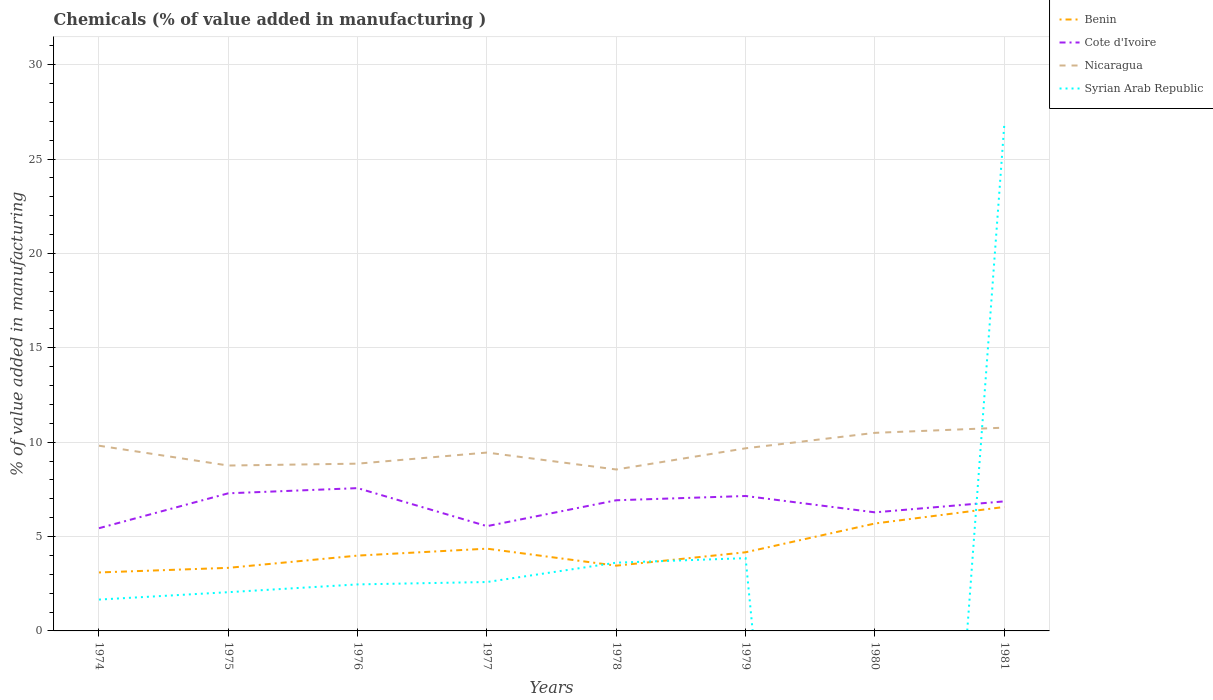How many different coloured lines are there?
Your answer should be very brief. 4. Across all years, what is the maximum value added in manufacturing chemicals in Nicaragua?
Offer a terse response. 8.55. What is the total value added in manufacturing chemicals in Benin in the graph?
Provide a succinct answer. -2.21. What is the difference between the highest and the second highest value added in manufacturing chemicals in Cote d'Ivoire?
Offer a very short reply. 2.12. What is the difference between the highest and the lowest value added in manufacturing chemicals in Cote d'Ivoire?
Ensure brevity in your answer.  5. Is the value added in manufacturing chemicals in Nicaragua strictly greater than the value added in manufacturing chemicals in Syrian Arab Republic over the years?
Make the answer very short. No. How many years are there in the graph?
Give a very brief answer. 8. What is the difference between two consecutive major ticks on the Y-axis?
Keep it short and to the point. 5. Are the values on the major ticks of Y-axis written in scientific E-notation?
Your response must be concise. No. Where does the legend appear in the graph?
Your answer should be compact. Top right. What is the title of the graph?
Provide a short and direct response. Chemicals (% of value added in manufacturing ). Does "Latvia" appear as one of the legend labels in the graph?
Your response must be concise. No. What is the label or title of the Y-axis?
Make the answer very short. % of value added in manufacturing. What is the % of value added in manufacturing in Benin in 1974?
Your response must be concise. 3.1. What is the % of value added in manufacturing in Cote d'Ivoire in 1974?
Provide a short and direct response. 5.44. What is the % of value added in manufacturing of Nicaragua in 1974?
Your response must be concise. 9.81. What is the % of value added in manufacturing in Syrian Arab Republic in 1974?
Your response must be concise. 1.66. What is the % of value added in manufacturing in Benin in 1975?
Your answer should be very brief. 3.34. What is the % of value added in manufacturing in Cote d'Ivoire in 1975?
Offer a very short reply. 7.29. What is the % of value added in manufacturing of Nicaragua in 1975?
Provide a short and direct response. 8.76. What is the % of value added in manufacturing in Syrian Arab Republic in 1975?
Offer a very short reply. 2.05. What is the % of value added in manufacturing in Benin in 1976?
Provide a short and direct response. 3.99. What is the % of value added in manufacturing of Cote d'Ivoire in 1976?
Your response must be concise. 7.56. What is the % of value added in manufacturing of Nicaragua in 1976?
Make the answer very short. 8.86. What is the % of value added in manufacturing in Syrian Arab Republic in 1976?
Your answer should be very brief. 2.46. What is the % of value added in manufacturing in Benin in 1977?
Your answer should be compact. 4.36. What is the % of value added in manufacturing of Cote d'Ivoire in 1977?
Make the answer very short. 5.55. What is the % of value added in manufacturing in Nicaragua in 1977?
Offer a terse response. 9.45. What is the % of value added in manufacturing of Syrian Arab Republic in 1977?
Ensure brevity in your answer.  2.59. What is the % of value added in manufacturing in Benin in 1978?
Ensure brevity in your answer.  3.46. What is the % of value added in manufacturing in Cote d'Ivoire in 1978?
Provide a short and direct response. 6.92. What is the % of value added in manufacturing of Nicaragua in 1978?
Ensure brevity in your answer.  8.55. What is the % of value added in manufacturing in Syrian Arab Republic in 1978?
Provide a succinct answer. 3.62. What is the % of value added in manufacturing in Benin in 1979?
Give a very brief answer. 4.17. What is the % of value added in manufacturing of Cote d'Ivoire in 1979?
Your answer should be compact. 7.15. What is the % of value added in manufacturing in Nicaragua in 1979?
Offer a terse response. 9.68. What is the % of value added in manufacturing in Syrian Arab Republic in 1979?
Make the answer very short. 3.85. What is the % of value added in manufacturing in Benin in 1980?
Provide a succinct answer. 5.69. What is the % of value added in manufacturing in Cote d'Ivoire in 1980?
Provide a succinct answer. 6.28. What is the % of value added in manufacturing in Nicaragua in 1980?
Make the answer very short. 10.49. What is the % of value added in manufacturing of Benin in 1981?
Provide a succinct answer. 6.57. What is the % of value added in manufacturing in Cote d'Ivoire in 1981?
Keep it short and to the point. 6.86. What is the % of value added in manufacturing in Nicaragua in 1981?
Offer a terse response. 10.77. What is the % of value added in manufacturing of Syrian Arab Republic in 1981?
Provide a short and direct response. 26.81. Across all years, what is the maximum % of value added in manufacturing of Benin?
Your answer should be compact. 6.57. Across all years, what is the maximum % of value added in manufacturing of Cote d'Ivoire?
Your answer should be compact. 7.56. Across all years, what is the maximum % of value added in manufacturing in Nicaragua?
Make the answer very short. 10.77. Across all years, what is the maximum % of value added in manufacturing of Syrian Arab Republic?
Make the answer very short. 26.81. Across all years, what is the minimum % of value added in manufacturing in Benin?
Offer a very short reply. 3.1. Across all years, what is the minimum % of value added in manufacturing of Cote d'Ivoire?
Ensure brevity in your answer.  5.44. Across all years, what is the minimum % of value added in manufacturing in Nicaragua?
Your answer should be very brief. 8.55. What is the total % of value added in manufacturing in Benin in the graph?
Provide a short and direct response. 34.67. What is the total % of value added in manufacturing in Cote d'Ivoire in the graph?
Offer a terse response. 53.07. What is the total % of value added in manufacturing in Nicaragua in the graph?
Offer a very short reply. 76.38. What is the total % of value added in manufacturing in Syrian Arab Republic in the graph?
Keep it short and to the point. 43.05. What is the difference between the % of value added in manufacturing in Benin in 1974 and that in 1975?
Your answer should be compact. -0.24. What is the difference between the % of value added in manufacturing in Cote d'Ivoire in 1974 and that in 1975?
Ensure brevity in your answer.  -1.85. What is the difference between the % of value added in manufacturing in Nicaragua in 1974 and that in 1975?
Provide a short and direct response. 1.05. What is the difference between the % of value added in manufacturing in Syrian Arab Republic in 1974 and that in 1975?
Offer a very short reply. -0.39. What is the difference between the % of value added in manufacturing of Benin in 1974 and that in 1976?
Give a very brief answer. -0.89. What is the difference between the % of value added in manufacturing in Cote d'Ivoire in 1974 and that in 1976?
Keep it short and to the point. -2.12. What is the difference between the % of value added in manufacturing of Nicaragua in 1974 and that in 1976?
Ensure brevity in your answer.  0.95. What is the difference between the % of value added in manufacturing in Syrian Arab Republic in 1974 and that in 1976?
Offer a terse response. -0.8. What is the difference between the % of value added in manufacturing of Benin in 1974 and that in 1977?
Give a very brief answer. -1.26. What is the difference between the % of value added in manufacturing in Cote d'Ivoire in 1974 and that in 1977?
Your answer should be compact. -0.11. What is the difference between the % of value added in manufacturing in Nicaragua in 1974 and that in 1977?
Offer a very short reply. 0.36. What is the difference between the % of value added in manufacturing in Syrian Arab Republic in 1974 and that in 1977?
Your answer should be compact. -0.93. What is the difference between the % of value added in manufacturing in Benin in 1974 and that in 1978?
Offer a very short reply. -0.36. What is the difference between the % of value added in manufacturing in Cote d'Ivoire in 1974 and that in 1978?
Your answer should be very brief. -1.48. What is the difference between the % of value added in manufacturing of Nicaragua in 1974 and that in 1978?
Your answer should be very brief. 1.26. What is the difference between the % of value added in manufacturing in Syrian Arab Republic in 1974 and that in 1978?
Your answer should be very brief. -1.95. What is the difference between the % of value added in manufacturing of Benin in 1974 and that in 1979?
Your answer should be very brief. -1.07. What is the difference between the % of value added in manufacturing of Cote d'Ivoire in 1974 and that in 1979?
Offer a very short reply. -1.71. What is the difference between the % of value added in manufacturing of Nicaragua in 1974 and that in 1979?
Keep it short and to the point. 0.14. What is the difference between the % of value added in manufacturing in Syrian Arab Republic in 1974 and that in 1979?
Provide a short and direct response. -2.19. What is the difference between the % of value added in manufacturing in Benin in 1974 and that in 1980?
Provide a succinct answer. -2.59. What is the difference between the % of value added in manufacturing in Cote d'Ivoire in 1974 and that in 1980?
Provide a succinct answer. -0.84. What is the difference between the % of value added in manufacturing in Nicaragua in 1974 and that in 1980?
Offer a terse response. -0.68. What is the difference between the % of value added in manufacturing of Benin in 1974 and that in 1981?
Keep it short and to the point. -3.47. What is the difference between the % of value added in manufacturing of Cote d'Ivoire in 1974 and that in 1981?
Give a very brief answer. -1.42. What is the difference between the % of value added in manufacturing of Nicaragua in 1974 and that in 1981?
Your answer should be very brief. -0.96. What is the difference between the % of value added in manufacturing of Syrian Arab Republic in 1974 and that in 1981?
Make the answer very short. -25.15. What is the difference between the % of value added in manufacturing in Benin in 1975 and that in 1976?
Give a very brief answer. -0.65. What is the difference between the % of value added in manufacturing in Cote d'Ivoire in 1975 and that in 1976?
Your answer should be very brief. -0.27. What is the difference between the % of value added in manufacturing in Nicaragua in 1975 and that in 1976?
Provide a succinct answer. -0.1. What is the difference between the % of value added in manufacturing in Syrian Arab Republic in 1975 and that in 1976?
Your answer should be very brief. -0.41. What is the difference between the % of value added in manufacturing in Benin in 1975 and that in 1977?
Provide a short and direct response. -1.02. What is the difference between the % of value added in manufacturing in Cote d'Ivoire in 1975 and that in 1977?
Provide a succinct answer. 1.74. What is the difference between the % of value added in manufacturing in Nicaragua in 1975 and that in 1977?
Offer a very short reply. -0.69. What is the difference between the % of value added in manufacturing in Syrian Arab Republic in 1975 and that in 1977?
Your response must be concise. -0.54. What is the difference between the % of value added in manufacturing in Benin in 1975 and that in 1978?
Keep it short and to the point. -0.12. What is the difference between the % of value added in manufacturing of Cote d'Ivoire in 1975 and that in 1978?
Your answer should be very brief. 0.37. What is the difference between the % of value added in manufacturing in Nicaragua in 1975 and that in 1978?
Offer a terse response. 0.21. What is the difference between the % of value added in manufacturing in Syrian Arab Republic in 1975 and that in 1978?
Your answer should be compact. -1.56. What is the difference between the % of value added in manufacturing of Benin in 1975 and that in 1979?
Offer a very short reply. -0.83. What is the difference between the % of value added in manufacturing of Cote d'Ivoire in 1975 and that in 1979?
Make the answer very short. 0.14. What is the difference between the % of value added in manufacturing in Nicaragua in 1975 and that in 1979?
Your response must be concise. -0.91. What is the difference between the % of value added in manufacturing in Syrian Arab Republic in 1975 and that in 1979?
Offer a terse response. -1.8. What is the difference between the % of value added in manufacturing in Benin in 1975 and that in 1980?
Your response must be concise. -2.35. What is the difference between the % of value added in manufacturing in Cote d'Ivoire in 1975 and that in 1980?
Ensure brevity in your answer.  1.01. What is the difference between the % of value added in manufacturing of Nicaragua in 1975 and that in 1980?
Give a very brief answer. -1.73. What is the difference between the % of value added in manufacturing of Benin in 1975 and that in 1981?
Give a very brief answer. -3.23. What is the difference between the % of value added in manufacturing in Cote d'Ivoire in 1975 and that in 1981?
Keep it short and to the point. 0.43. What is the difference between the % of value added in manufacturing in Nicaragua in 1975 and that in 1981?
Your response must be concise. -2.01. What is the difference between the % of value added in manufacturing of Syrian Arab Republic in 1975 and that in 1981?
Offer a very short reply. -24.76. What is the difference between the % of value added in manufacturing of Benin in 1976 and that in 1977?
Give a very brief answer. -0.37. What is the difference between the % of value added in manufacturing of Cote d'Ivoire in 1976 and that in 1977?
Provide a succinct answer. 2.01. What is the difference between the % of value added in manufacturing of Nicaragua in 1976 and that in 1977?
Ensure brevity in your answer.  -0.59. What is the difference between the % of value added in manufacturing of Syrian Arab Republic in 1976 and that in 1977?
Offer a very short reply. -0.13. What is the difference between the % of value added in manufacturing in Benin in 1976 and that in 1978?
Offer a very short reply. 0.53. What is the difference between the % of value added in manufacturing in Cote d'Ivoire in 1976 and that in 1978?
Offer a terse response. 0.64. What is the difference between the % of value added in manufacturing in Nicaragua in 1976 and that in 1978?
Give a very brief answer. 0.31. What is the difference between the % of value added in manufacturing of Syrian Arab Republic in 1976 and that in 1978?
Offer a terse response. -1.15. What is the difference between the % of value added in manufacturing in Benin in 1976 and that in 1979?
Offer a very short reply. -0.18. What is the difference between the % of value added in manufacturing in Cote d'Ivoire in 1976 and that in 1979?
Your response must be concise. 0.42. What is the difference between the % of value added in manufacturing in Nicaragua in 1976 and that in 1979?
Keep it short and to the point. -0.81. What is the difference between the % of value added in manufacturing in Syrian Arab Republic in 1976 and that in 1979?
Offer a very short reply. -1.39. What is the difference between the % of value added in manufacturing of Benin in 1976 and that in 1980?
Your answer should be compact. -1.7. What is the difference between the % of value added in manufacturing of Cote d'Ivoire in 1976 and that in 1980?
Give a very brief answer. 1.28. What is the difference between the % of value added in manufacturing in Nicaragua in 1976 and that in 1980?
Make the answer very short. -1.63. What is the difference between the % of value added in manufacturing in Benin in 1976 and that in 1981?
Keep it short and to the point. -2.58. What is the difference between the % of value added in manufacturing of Cote d'Ivoire in 1976 and that in 1981?
Your answer should be compact. 0.7. What is the difference between the % of value added in manufacturing of Nicaragua in 1976 and that in 1981?
Offer a terse response. -1.91. What is the difference between the % of value added in manufacturing of Syrian Arab Republic in 1976 and that in 1981?
Your answer should be very brief. -24.34. What is the difference between the % of value added in manufacturing of Benin in 1977 and that in 1978?
Make the answer very short. 0.9. What is the difference between the % of value added in manufacturing of Cote d'Ivoire in 1977 and that in 1978?
Offer a very short reply. -1.37. What is the difference between the % of value added in manufacturing in Nicaragua in 1977 and that in 1978?
Provide a short and direct response. 0.9. What is the difference between the % of value added in manufacturing of Syrian Arab Republic in 1977 and that in 1978?
Your response must be concise. -1.02. What is the difference between the % of value added in manufacturing in Benin in 1977 and that in 1979?
Your response must be concise. 0.19. What is the difference between the % of value added in manufacturing of Cote d'Ivoire in 1977 and that in 1979?
Ensure brevity in your answer.  -1.6. What is the difference between the % of value added in manufacturing in Nicaragua in 1977 and that in 1979?
Give a very brief answer. -0.23. What is the difference between the % of value added in manufacturing of Syrian Arab Republic in 1977 and that in 1979?
Your response must be concise. -1.26. What is the difference between the % of value added in manufacturing in Benin in 1977 and that in 1980?
Keep it short and to the point. -1.33. What is the difference between the % of value added in manufacturing of Cote d'Ivoire in 1977 and that in 1980?
Provide a short and direct response. -0.73. What is the difference between the % of value added in manufacturing in Nicaragua in 1977 and that in 1980?
Offer a very short reply. -1.04. What is the difference between the % of value added in manufacturing in Benin in 1977 and that in 1981?
Your answer should be compact. -2.21. What is the difference between the % of value added in manufacturing of Cote d'Ivoire in 1977 and that in 1981?
Offer a very short reply. -1.31. What is the difference between the % of value added in manufacturing of Nicaragua in 1977 and that in 1981?
Your response must be concise. -1.32. What is the difference between the % of value added in manufacturing of Syrian Arab Republic in 1977 and that in 1981?
Your response must be concise. -24.22. What is the difference between the % of value added in manufacturing of Benin in 1978 and that in 1979?
Offer a terse response. -0.71. What is the difference between the % of value added in manufacturing of Cote d'Ivoire in 1978 and that in 1979?
Offer a terse response. -0.23. What is the difference between the % of value added in manufacturing in Nicaragua in 1978 and that in 1979?
Keep it short and to the point. -1.12. What is the difference between the % of value added in manufacturing of Syrian Arab Republic in 1978 and that in 1979?
Ensure brevity in your answer.  -0.24. What is the difference between the % of value added in manufacturing in Benin in 1978 and that in 1980?
Offer a very short reply. -2.23. What is the difference between the % of value added in manufacturing of Cote d'Ivoire in 1978 and that in 1980?
Ensure brevity in your answer.  0.64. What is the difference between the % of value added in manufacturing in Nicaragua in 1978 and that in 1980?
Your answer should be very brief. -1.94. What is the difference between the % of value added in manufacturing in Benin in 1978 and that in 1981?
Offer a very short reply. -3.11. What is the difference between the % of value added in manufacturing of Cote d'Ivoire in 1978 and that in 1981?
Your response must be concise. 0.06. What is the difference between the % of value added in manufacturing in Nicaragua in 1978 and that in 1981?
Provide a short and direct response. -2.22. What is the difference between the % of value added in manufacturing in Syrian Arab Republic in 1978 and that in 1981?
Make the answer very short. -23.19. What is the difference between the % of value added in manufacturing in Benin in 1979 and that in 1980?
Make the answer very short. -1.52. What is the difference between the % of value added in manufacturing of Cote d'Ivoire in 1979 and that in 1980?
Provide a succinct answer. 0.87. What is the difference between the % of value added in manufacturing of Nicaragua in 1979 and that in 1980?
Your response must be concise. -0.82. What is the difference between the % of value added in manufacturing of Benin in 1979 and that in 1981?
Your answer should be very brief. -2.4. What is the difference between the % of value added in manufacturing in Cote d'Ivoire in 1979 and that in 1981?
Give a very brief answer. 0.28. What is the difference between the % of value added in manufacturing in Nicaragua in 1979 and that in 1981?
Your answer should be compact. -1.09. What is the difference between the % of value added in manufacturing of Syrian Arab Republic in 1979 and that in 1981?
Offer a terse response. -22.95. What is the difference between the % of value added in manufacturing in Benin in 1980 and that in 1981?
Give a very brief answer. -0.88. What is the difference between the % of value added in manufacturing in Cote d'Ivoire in 1980 and that in 1981?
Give a very brief answer. -0.58. What is the difference between the % of value added in manufacturing in Nicaragua in 1980 and that in 1981?
Provide a short and direct response. -0.27. What is the difference between the % of value added in manufacturing of Benin in 1974 and the % of value added in manufacturing of Cote d'Ivoire in 1975?
Offer a terse response. -4.19. What is the difference between the % of value added in manufacturing of Benin in 1974 and the % of value added in manufacturing of Nicaragua in 1975?
Your answer should be very brief. -5.66. What is the difference between the % of value added in manufacturing of Benin in 1974 and the % of value added in manufacturing of Syrian Arab Republic in 1975?
Offer a terse response. 1.05. What is the difference between the % of value added in manufacturing of Cote d'Ivoire in 1974 and the % of value added in manufacturing of Nicaragua in 1975?
Ensure brevity in your answer.  -3.32. What is the difference between the % of value added in manufacturing in Cote d'Ivoire in 1974 and the % of value added in manufacturing in Syrian Arab Republic in 1975?
Offer a very short reply. 3.39. What is the difference between the % of value added in manufacturing of Nicaragua in 1974 and the % of value added in manufacturing of Syrian Arab Republic in 1975?
Your answer should be compact. 7.76. What is the difference between the % of value added in manufacturing of Benin in 1974 and the % of value added in manufacturing of Cote d'Ivoire in 1976?
Give a very brief answer. -4.47. What is the difference between the % of value added in manufacturing of Benin in 1974 and the % of value added in manufacturing of Nicaragua in 1976?
Ensure brevity in your answer.  -5.76. What is the difference between the % of value added in manufacturing in Benin in 1974 and the % of value added in manufacturing in Syrian Arab Republic in 1976?
Your answer should be compact. 0.63. What is the difference between the % of value added in manufacturing in Cote d'Ivoire in 1974 and the % of value added in manufacturing in Nicaragua in 1976?
Provide a succinct answer. -3.42. What is the difference between the % of value added in manufacturing of Cote d'Ivoire in 1974 and the % of value added in manufacturing of Syrian Arab Republic in 1976?
Give a very brief answer. 2.98. What is the difference between the % of value added in manufacturing in Nicaragua in 1974 and the % of value added in manufacturing in Syrian Arab Republic in 1976?
Offer a terse response. 7.35. What is the difference between the % of value added in manufacturing of Benin in 1974 and the % of value added in manufacturing of Cote d'Ivoire in 1977?
Offer a very short reply. -2.45. What is the difference between the % of value added in manufacturing in Benin in 1974 and the % of value added in manufacturing in Nicaragua in 1977?
Your response must be concise. -6.35. What is the difference between the % of value added in manufacturing of Benin in 1974 and the % of value added in manufacturing of Syrian Arab Republic in 1977?
Your answer should be very brief. 0.51. What is the difference between the % of value added in manufacturing of Cote d'Ivoire in 1974 and the % of value added in manufacturing of Nicaragua in 1977?
Make the answer very short. -4.01. What is the difference between the % of value added in manufacturing of Cote d'Ivoire in 1974 and the % of value added in manufacturing of Syrian Arab Republic in 1977?
Ensure brevity in your answer.  2.85. What is the difference between the % of value added in manufacturing of Nicaragua in 1974 and the % of value added in manufacturing of Syrian Arab Republic in 1977?
Your response must be concise. 7.22. What is the difference between the % of value added in manufacturing of Benin in 1974 and the % of value added in manufacturing of Cote d'Ivoire in 1978?
Your answer should be compact. -3.82. What is the difference between the % of value added in manufacturing of Benin in 1974 and the % of value added in manufacturing of Nicaragua in 1978?
Ensure brevity in your answer.  -5.45. What is the difference between the % of value added in manufacturing in Benin in 1974 and the % of value added in manufacturing in Syrian Arab Republic in 1978?
Your answer should be very brief. -0.52. What is the difference between the % of value added in manufacturing in Cote d'Ivoire in 1974 and the % of value added in manufacturing in Nicaragua in 1978?
Offer a very short reply. -3.11. What is the difference between the % of value added in manufacturing in Cote d'Ivoire in 1974 and the % of value added in manufacturing in Syrian Arab Republic in 1978?
Provide a succinct answer. 1.83. What is the difference between the % of value added in manufacturing in Nicaragua in 1974 and the % of value added in manufacturing in Syrian Arab Republic in 1978?
Provide a short and direct response. 6.2. What is the difference between the % of value added in manufacturing in Benin in 1974 and the % of value added in manufacturing in Cote d'Ivoire in 1979?
Your answer should be very brief. -4.05. What is the difference between the % of value added in manufacturing in Benin in 1974 and the % of value added in manufacturing in Nicaragua in 1979?
Offer a very short reply. -6.58. What is the difference between the % of value added in manufacturing of Benin in 1974 and the % of value added in manufacturing of Syrian Arab Republic in 1979?
Give a very brief answer. -0.76. What is the difference between the % of value added in manufacturing in Cote d'Ivoire in 1974 and the % of value added in manufacturing in Nicaragua in 1979?
Provide a succinct answer. -4.23. What is the difference between the % of value added in manufacturing of Cote d'Ivoire in 1974 and the % of value added in manufacturing of Syrian Arab Republic in 1979?
Offer a terse response. 1.59. What is the difference between the % of value added in manufacturing of Nicaragua in 1974 and the % of value added in manufacturing of Syrian Arab Republic in 1979?
Make the answer very short. 5.96. What is the difference between the % of value added in manufacturing in Benin in 1974 and the % of value added in manufacturing in Cote d'Ivoire in 1980?
Provide a short and direct response. -3.18. What is the difference between the % of value added in manufacturing of Benin in 1974 and the % of value added in manufacturing of Nicaragua in 1980?
Keep it short and to the point. -7.4. What is the difference between the % of value added in manufacturing of Cote d'Ivoire in 1974 and the % of value added in manufacturing of Nicaragua in 1980?
Offer a terse response. -5.05. What is the difference between the % of value added in manufacturing in Benin in 1974 and the % of value added in manufacturing in Cote d'Ivoire in 1981?
Offer a very short reply. -3.77. What is the difference between the % of value added in manufacturing of Benin in 1974 and the % of value added in manufacturing of Nicaragua in 1981?
Give a very brief answer. -7.67. What is the difference between the % of value added in manufacturing in Benin in 1974 and the % of value added in manufacturing in Syrian Arab Republic in 1981?
Your answer should be very brief. -23.71. What is the difference between the % of value added in manufacturing in Cote d'Ivoire in 1974 and the % of value added in manufacturing in Nicaragua in 1981?
Offer a very short reply. -5.33. What is the difference between the % of value added in manufacturing in Cote d'Ivoire in 1974 and the % of value added in manufacturing in Syrian Arab Republic in 1981?
Give a very brief answer. -21.37. What is the difference between the % of value added in manufacturing in Nicaragua in 1974 and the % of value added in manufacturing in Syrian Arab Republic in 1981?
Your answer should be compact. -17. What is the difference between the % of value added in manufacturing of Benin in 1975 and the % of value added in manufacturing of Cote d'Ivoire in 1976?
Provide a short and direct response. -4.22. What is the difference between the % of value added in manufacturing of Benin in 1975 and the % of value added in manufacturing of Nicaragua in 1976?
Provide a short and direct response. -5.52. What is the difference between the % of value added in manufacturing of Benin in 1975 and the % of value added in manufacturing of Syrian Arab Republic in 1976?
Provide a short and direct response. 0.88. What is the difference between the % of value added in manufacturing in Cote d'Ivoire in 1975 and the % of value added in manufacturing in Nicaragua in 1976?
Make the answer very short. -1.57. What is the difference between the % of value added in manufacturing of Cote d'Ivoire in 1975 and the % of value added in manufacturing of Syrian Arab Republic in 1976?
Offer a very short reply. 4.83. What is the difference between the % of value added in manufacturing of Nicaragua in 1975 and the % of value added in manufacturing of Syrian Arab Republic in 1976?
Make the answer very short. 6.3. What is the difference between the % of value added in manufacturing in Benin in 1975 and the % of value added in manufacturing in Cote d'Ivoire in 1977?
Keep it short and to the point. -2.21. What is the difference between the % of value added in manufacturing in Benin in 1975 and the % of value added in manufacturing in Nicaragua in 1977?
Keep it short and to the point. -6.11. What is the difference between the % of value added in manufacturing in Benin in 1975 and the % of value added in manufacturing in Syrian Arab Republic in 1977?
Provide a short and direct response. 0.75. What is the difference between the % of value added in manufacturing in Cote d'Ivoire in 1975 and the % of value added in manufacturing in Nicaragua in 1977?
Ensure brevity in your answer.  -2.16. What is the difference between the % of value added in manufacturing in Cote d'Ivoire in 1975 and the % of value added in manufacturing in Syrian Arab Republic in 1977?
Provide a succinct answer. 4.7. What is the difference between the % of value added in manufacturing of Nicaragua in 1975 and the % of value added in manufacturing of Syrian Arab Republic in 1977?
Keep it short and to the point. 6.17. What is the difference between the % of value added in manufacturing of Benin in 1975 and the % of value added in manufacturing of Cote d'Ivoire in 1978?
Your answer should be compact. -3.58. What is the difference between the % of value added in manufacturing of Benin in 1975 and the % of value added in manufacturing of Nicaragua in 1978?
Your response must be concise. -5.21. What is the difference between the % of value added in manufacturing of Benin in 1975 and the % of value added in manufacturing of Syrian Arab Republic in 1978?
Your answer should be compact. -0.27. What is the difference between the % of value added in manufacturing of Cote d'Ivoire in 1975 and the % of value added in manufacturing of Nicaragua in 1978?
Ensure brevity in your answer.  -1.26. What is the difference between the % of value added in manufacturing in Cote d'Ivoire in 1975 and the % of value added in manufacturing in Syrian Arab Republic in 1978?
Provide a short and direct response. 3.68. What is the difference between the % of value added in manufacturing of Nicaragua in 1975 and the % of value added in manufacturing of Syrian Arab Republic in 1978?
Your answer should be very brief. 5.15. What is the difference between the % of value added in manufacturing of Benin in 1975 and the % of value added in manufacturing of Cote d'Ivoire in 1979?
Keep it short and to the point. -3.81. What is the difference between the % of value added in manufacturing in Benin in 1975 and the % of value added in manufacturing in Nicaragua in 1979?
Offer a terse response. -6.33. What is the difference between the % of value added in manufacturing of Benin in 1975 and the % of value added in manufacturing of Syrian Arab Republic in 1979?
Your answer should be very brief. -0.51. What is the difference between the % of value added in manufacturing of Cote d'Ivoire in 1975 and the % of value added in manufacturing of Nicaragua in 1979?
Make the answer very short. -2.38. What is the difference between the % of value added in manufacturing in Cote d'Ivoire in 1975 and the % of value added in manufacturing in Syrian Arab Republic in 1979?
Give a very brief answer. 3.44. What is the difference between the % of value added in manufacturing in Nicaragua in 1975 and the % of value added in manufacturing in Syrian Arab Republic in 1979?
Ensure brevity in your answer.  4.91. What is the difference between the % of value added in manufacturing of Benin in 1975 and the % of value added in manufacturing of Cote d'Ivoire in 1980?
Keep it short and to the point. -2.94. What is the difference between the % of value added in manufacturing of Benin in 1975 and the % of value added in manufacturing of Nicaragua in 1980?
Provide a short and direct response. -7.15. What is the difference between the % of value added in manufacturing in Cote d'Ivoire in 1975 and the % of value added in manufacturing in Nicaragua in 1980?
Make the answer very short. -3.2. What is the difference between the % of value added in manufacturing in Benin in 1975 and the % of value added in manufacturing in Cote d'Ivoire in 1981?
Offer a terse response. -3.52. What is the difference between the % of value added in manufacturing in Benin in 1975 and the % of value added in manufacturing in Nicaragua in 1981?
Your response must be concise. -7.43. What is the difference between the % of value added in manufacturing of Benin in 1975 and the % of value added in manufacturing of Syrian Arab Republic in 1981?
Your answer should be compact. -23.47. What is the difference between the % of value added in manufacturing in Cote d'Ivoire in 1975 and the % of value added in manufacturing in Nicaragua in 1981?
Your response must be concise. -3.48. What is the difference between the % of value added in manufacturing in Cote d'Ivoire in 1975 and the % of value added in manufacturing in Syrian Arab Republic in 1981?
Keep it short and to the point. -19.52. What is the difference between the % of value added in manufacturing of Nicaragua in 1975 and the % of value added in manufacturing of Syrian Arab Republic in 1981?
Offer a very short reply. -18.05. What is the difference between the % of value added in manufacturing in Benin in 1976 and the % of value added in manufacturing in Cote d'Ivoire in 1977?
Keep it short and to the point. -1.56. What is the difference between the % of value added in manufacturing of Benin in 1976 and the % of value added in manufacturing of Nicaragua in 1977?
Your response must be concise. -5.46. What is the difference between the % of value added in manufacturing in Benin in 1976 and the % of value added in manufacturing in Syrian Arab Republic in 1977?
Your answer should be compact. 1.4. What is the difference between the % of value added in manufacturing of Cote d'Ivoire in 1976 and the % of value added in manufacturing of Nicaragua in 1977?
Provide a succinct answer. -1.88. What is the difference between the % of value added in manufacturing in Cote d'Ivoire in 1976 and the % of value added in manufacturing in Syrian Arab Republic in 1977?
Keep it short and to the point. 4.97. What is the difference between the % of value added in manufacturing of Nicaragua in 1976 and the % of value added in manufacturing of Syrian Arab Republic in 1977?
Make the answer very short. 6.27. What is the difference between the % of value added in manufacturing of Benin in 1976 and the % of value added in manufacturing of Cote d'Ivoire in 1978?
Offer a terse response. -2.93. What is the difference between the % of value added in manufacturing of Benin in 1976 and the % of value added in manufacturing of Nicaragua in 1978?
Keep it short and to the point. -4.56. What is the difference between the % of value added in manufacturing in Benin in 1976 and the % of value added in manufacturing in Syrian Arab Republic in 1978?
Offer a terse response. 0.37. What is the difference between the % of value added in manufacturing in Cote d'Ivoire in 1976 and the % of value added in manufacturing in Nicaragua in 1978?
Offer a very short reply. -0.99. What is the difference between the % of value added in manufacturing of Cote d'Ivoire in 1976 and the % of value added in manufacturing of Syrian Arab Republic in 1978?
Offer a very short reply. 3.95. What is the difference between the % of value added in manufacturing in Nicaragua in 1976 and the % of value added in manufacturing in Syrian Arab Republic in 1978?
Give a very brief answer. 5.25. What is the difference between the % of value added in manufacturing of Benin in 1976 and the % of value added in manufacturing of Cote d'Ivoire in 1979?
Your answer should be compact. -3.16. What is the difference between the % of value added in manufacturing in Benin in 1976 and the % of value added in manufacturing in Nicaragua in 1979?
Make the answer very short. -5.69. What is the difference between the % of value added in manufacturing of Benin in 1976 and the % of value added in manufacturing of Syrian Arab Republic in 1979?
Your response must be concise. 0.14. What is the difference between the % of value added in manufacturing in Cote d'Ivoire in 1976 and the % of value added in manufacturing in Nicaragua in 1979?
Keep it short and to the point. -2.11. What is the difference between the % of value added in manufacturing of Cote d'Ivoire in 1976 and the % of value added in manufacturing of Syrian Arab Republic in 1979?
Give a very brief answer. 3.71. What is the difference between the % of value added in manufacturing in Nicaragua in 1976 and the % of value added in manufacturing in Syrian Arab Republic in 1979?
Provide a short and direct response. 5.01. What is the difference between the % of value added in manufacturing in Benin in 1976 and the % of value added in manufacturing in Cote d'Ivoire in 1980?
Make the answer very short. -2.29. What is the difference between the % of value added in manufacturing in Benin in 1976 and the % of value added in manufacturing in Nicaragua in 1980?
Provide a short and direct response. -6.5. What is the difference between the % of value added in manufacturing in Cote d'Ivoire in 1976 and the % of value added in manufacturing in Nicaragua in 1980?
Ensure brevity in your answer.  -2.93. What is the difference between the % of value added in manufacturing in Benin in 1976 and the % of value added in manufacturing in Cote d'Ivoire in 1981?
Provide a succinct answer. -2.87. What is the difference between the % of value added in manufacturing of Benin in 1976 and the % of value added in manufacturing of Nicaragua in 1981?
Give a very brief answer. -6.78. What is the difference between the % of value added in manufacturing of Benin in 1976 and the % of value added in manufacturing of Syrian Arab Republic in 1981?
Your answer should be very brief. -22.82. What is the difference between the % of value added in manufacturing in Cote d'Ivoire in 1976 and the % of value added in manufacturing in Nicaragua in 1981?
Provide a succinct answer. -3.2. What is the difference between the % of value added in manufacturing of Cote d'Ivoire in 1976 and the % of value added in manufacturing of Syrian Arab Republic in 1981?
Make the answer very short. -19.24. What is the difference between the % of value added in manufacturing of Nicaragua in 1976 and the % of value added in manufacturing of Syrian Arab Republic in 1981?
Provide a short and direct response. -17.95. What is the difference between the % of value added in manufacturing of Benin in 1977 and the % of value added in manufacturing of Cote d'Ivoire in 1978?
Keep it short and to the point. -2.56. What is the difference between the % of value added in manufacturing of Benin in 1977 and the % of value added in manufacturing of Nicaragua in 1978?
Offer a very short reply. -4.19. What is the difference between the % of value added in manufacturing in Benin in 1977 and the % of value added in manufacturing in Syrian Arab Republic in 1978?
Your response must be concise. 0.74. What is the difference between the % of value added in manufacturing in Cote d'Ivoire in 1977 and the % of value added in manufacturing in Nicaragua in 1978?
Your answer should be compact. -3. What is the difference between the % of value added in manufacturing of Cote d'Ivoire in 1977 and the % of value added in manufacturing of Syrian Arab Republic in 1978?
Provide a succinct answer. 1.93. What is the difference between the % of value added in manufacturing in Nicaragua in 1977 and the % of value added in manufacturing in Syrian Arab Republic in 1978?
Your answer should be very brief. 5.83. What is the difference between the % of value added in manufacturing in Benin in 1977 and the % of value added in manufacturing in Cote d'Ivoire in 1979?
Offer a very short reply. -2.79. What is the difference between the % of value added in manufacturing of Benin in 1977 and the % of value added in manufacturing of Nicaragua in 1979?
Keep it short and to the point. -5.32. What is the difference between the % of value added in manufacturing in Benin in 1977 and the % of value added in manufacturing in Syrian Arab Republic in 1979?
Keep it short and to the point. 0.5. What is the difference between the % of value added in manufacturing of Cote d'Ivoire in 1977 and the % of value added in manufacturing of Nicaragua in 1979?
Provide a short and direct response. -4.12. What is the difference between the % of value added in manufacturing of Cote d'Ivoire in 1977 and the % of value added in manufacturing of Syrian Arab Republic in 1979?
Offer a terse response. 1.7. What is the difference between the % of value added in manufacturing in Nicaragua in 1977 and the % of value added in manufacturing in Syrian Arab Republic in 1979?
Provide a succinct answer. 5.59. What is the difference between the % of value added in manufacturing in Benin in 1977 and the % of value added in manufacturing in Cote d'Ivoire in 1980?
Give a very brief answer. -1.92. What is the difference between the % of value added in manufacturing of Benin in 1977 and the % of value added in manufacturing of Nicaragua in 1980?
Offer a very short reply. -6.14. What is the difference between the % of value added in manufacturing of Cote d'Ivoire in 1977 and the % of value added in manufacturing of Nicaragua in 1980?
Your answer should be compact. -4.94. What is the difference between the % of value added in manufacturing in Benin in 1977 and the % of value added in manufacturing in Cote d'Ivoire in 1981?
Make the answer very short. -2.51. What is the difference between the % of value added in manufacturing in Benin in 1977 and the % of value added in manufacturing in Nicaragua in 1981?
Ensure brevity in your answer.  -6.41. What is the difference between the % of value added in manufacturing in Benin in 1977 and the % of value added in manufacturing in Syrian Arab Republic in 1981?
Your answer should be compact. -22.45. What is the difference between the % of value added in manufacturing in Cote d'Ivoire in 1977 and the % of value added in manufacturing in Nicaragua in 1981?
Your response must be concise. -5.22. What is the difference between the % of value added in manufacturing in Cote d'Ivoire in 1977 and the % of value added in manufacturing in Syrian Arab Republic in 1981?
Provide a short and direct response. -21.26. What is the difference between the % of value added in manufacturing in Nicaragua in 1977 and the % of value added in manufacturing in Syrian Arab Republic in 1981?
Keep it short and to the point. -17.36. What is the difference between the % of value added in manufacturing in Benin in 1978 and the % of value added in manufacturing in Cote d'Ivoire in 1979?
Offer a terse response. -3.69. What is the difference between the % of value added in manufacturing of Benin in 1978 and the % of value added in manufacturing of Nicaragua in 1979?
Make the answer very short. -6.22. What is the difference between the % of value added in manufacturing in Benin in 1978 and the % of value added in manufacturing in Syrian Arab Republic in 1979?
Make the answer very short. -0.4. What is the difference between the % of value added in manufacturing of Cote d'Ivoire in 1978 and the % of value added in manufacturing of Nicaragua in 1979?
Your answer should be compact. -2.75. What is the difference between the % of value added in manufacturing of Cote d'Ivoire in 1978 and the % of value added in manufacturing of Syrian Arab Republic in 1979?
Provide a short and direct response. 3.07. What is the difference between the % of value added in manufacturing in Nicaragua in 1978 and the % of value added in manufacturing in Syrian Arab Republic in 1979?
Keep it short and to the point. 4.7. What is the difference between the % of value added in manufacturing of Benin in 1978 and the % of value added in manufacturing of Cote d'Ivoire in 1980?
Offer a terse response. -2.83. What is the difference between the % of value added in manufacturing in Benin in 1978 and the % of value added in manufacturing in Nicaragua in 1980?
Keep it short and to the point. -7.04. What is the difference between the % of value added in manufacturing in Cote d'Ivoire in 1978 and the % of value added in manufacturing in Nicaragua in 1980?
Give a very brief answer. -3.57. What is the difference between the % of value added in manufacturing in Benin in 1978 and the % of value added in manufacturing in Cote d'Ivoire in 1981?
Give a very brief answer. -3.41. What is the difference between the % of value added in manufacturing in Benin in 1978 and the % of value added in manufacturing in Nicaragua in 1981?
Your answer should be very brief. -7.31. What is the difference between the % of value added in manufacturing in Benin in 1978 and the % of value added in manufacturing in Syrian Arab Republic in 1981?
Offer a terse response. -23.35. What is the difference between the % of value added in manufacturing in Cote d'Ivoire in 1978 and the % of value added in manufacturing in Nicaragua in 1981?
Ensure brevity in your answer.  -3.85. What is the difference between the % of value added in manufacturing of Cote d'Ivoire in 1978 and the % of value added in manufacturing of Syrian Arab Republic in 1981?
Keep it short and to the point. -19.89. What is the difference between the % of value added in manufacturing of Nicaragua in 1978 and the % of value added in manufacturing of Syrian Arab Republic in 1981?
Your answer should be compact. -18.26. What is the difference between the % of value added in manufacturing in Benin in 1979 and the % of value added in manufacturing in Cote d'Ivoire in 1980?
Make the answer very short. -2.12. What is the difference between the % of value added in manufacturing of Benin in 1979 and the % of value added in manufacturing of Nicaragua in 1980?
Your response must be concise. -6.33. What is the difference between the % of value added in manufacturing in Cote d'Ivoire in 1979 and the % of value added in manufacturing in Nicaragua in 1980?
Offer a terse response. -3.35. What is the difference between the % of value added in manufacturing in Benin in 1979 and the % of value added in manufacturing in Cote d'Ivoire in 1981?
Provide a short and direct response. -2.7. What is the difference between the % of value added in manufacturing in Benin in 1979 and the % of value added in manufacturing in Nicaragua in 1981?
Provide a succinct answer. -6.6. What is the difference between the % of value added in manufacturing in Benin in 1979 and the % of value added in manufacturing in Syrian Arab Republic in 1981?
Offer a terse response. -22.64. What is the difference between the % of value added in manufacturing in Cote d'Ivoire in 1979 and the % of value added in manufacturing in Nicaragua in 1981?
Offer a very short reply. -3.62. What is the difference between the % of value added in manufacturing of Cote d'Ivoire in 1979 and the % of value added in manufacturing of Syrian Arab Republic in 1981?
Ensure brevity in your answer.  -19.66. What is the difference between the % of value added in manufacturing in Nicaragua in 1979 and the % of value added in manufacturing in Syrian Arab Republic in 1981?
Offer a terse response. -17.13. What is the difference between the % of value added in manufacturing in Benin in 1980 and the % of value added in manufacturing in Cote d'Ivoire in 1981?
Your response must be concise. -1.17. What is the difference between the % of value added in manufacturing of Benin in 1980 and the % of value added in manufacturing of Nicaragua in 1981?
Your answer should be very brief. -5.08. What is the difference between the % of value added in manufacturing of Benin in 1980 and the % of value added in manufacturing of Syrian Arab Republic in 1981?
Provide a succinct answer. -21.12. What is the difference between the % of value added in manufacturing of Cote d'Ivoire in 1980 and the % of value added in manufacturing of Nicaragua in 1981?
Keep it short and to the point. -4.49. What is the difference between the % of value added in manufacturing of Cote d'Ivoire in 1980 and the % of value added in manufacturing of Syrian Arab Republic in 1981?
Give a very brief answer. -20.53. What is the difference between the % of value added in manufacturing in Nicaragua in 1980 and the % of value added in manufacturing in Syrian Arab Republic in 1981?
Your answer should be compact. -16.32. What is the average % of value added in manufacturing in Benin per year?
Your answer should be compact. 4.33. What is the average % of value added in manufacturing of Cote d'Ivoire per year?
Give a very brief answer. 6.63. What is the average % of value added in manufacturing of Nicaragua per year?
Keep it short and to the point. 9.55. What is the average % of value added in manufacturing of Syrian Arab Republic per year?
Your response must be concise. 5.38. In the year 1974, what is the difference between the % of value added in manufacturing in Benin and % of value added in manufacturing in Cote d'Ivoire?
Your answer should be very brief. -2.34. In the year 1974, what is the difference between the % of value added in manufacturing in Benin and % of value added in manufacturing in Nicaragua?
Ensure brevity in your answer.  -6.71. In the year 1974, what is the difference between the % of value added in manufacturing of Benin and % of value added in manufacturing of Syrian Arab Republic?
Make the answer very short. 1.44. In the year 1974, what is the difference between the % of value added in manufacturing of Cote d'Ivoire and % of value added in manufacturing of Nicaragua?
Offer a terse response. -4.37. In the year 1974, what is the difference between the % of value added in manufacturing of Cote d'Ivoire and % of value added in manufacturing of Syrian Arab Republic?
Offer a very short reply. 3.78. In the year 1974, what is the difference between the % of value added in manufacturing in Nicaragua and % of value added in manufacturing in Syrian Arab Republic?
Your answer should be compact. 8.15. In the year 1975, what is the difference between the % of value added in manufacturing in Benin and % of value added in manufacturing in Cote d'Ivoire?
Make the answer very short. -3.95. In the year 1975, what is the difference between the % of value added in manufacturing of Benin and % of value added in manufacturing of Nicaragua?
Give a very brief answer. -5.42. In the year 1975, what is the difference between the % of value added in manufacturing of Benin and % of value added in manufacturing of Syrian Arab Republic?
Provide a short and direct response. 1.29. In the year 1975, what is the difference between the % of value added in manufacturing in Cote d'Ivoire and % of value added in manufacturing in Nicaragua?
Keep it short and to the point. -1.47. In the year 1975, what is the difference between the % of value added in manufacturing in Cote d'Ivoire and % of value added in manufacturing in Syrian Arab Republic?
Ensure brevity in your answer.  5.24. In the year 1975, what is the difference between the % of value added in manufacturing of Nicaragua and % of value added in manufacturing of Syrian Arab Republic?
Provide a short and direct response. 6.71. In the year 1976, what is the difference between the % of value added in manufacturing of Benin and % of value added in manufacturing of Cote d'Ivoire?
Keep it short and to the point. -3.57. In the year 1976, what is the difference between the % of value added in manufacturing in Benin and % of value added in manufacturing in Nicaragua?
Ensure brevity in your answer.  -4.87. In the year 1976, what is the difference between the % of value added in manufacturing in Benin and % of value added in manufacturing in Syrian Arab Republic?
Your answer should be very brief. 1.53. In the year 1976, what is the difference between the % of value added in manufacturing of Cote d'Ivoire and % of value added in manufacturing of Nicaragua?
Your answer should be very brief. -1.3. In the year 1976, what is the difference between the % of value added in manufacturing of Cote d'Ivoire and % of value added in manufacturing of Syrian Arab Republic?
Ensure brevity in your answer.  5.1. In the year 1976, what is the difference between the % of value added in manufacturing in Nicaragua and % of value added in manufacturing in Syrian Arab Republic?
Your answer should be compact. 6.4. In the year 1977, what is the difference between the % of value added in manufacturing in Benin and % of value added in manufacturing in Cote d'Ivoire?
Keep it short and to the point. -1.19. In the year 1977, what is the difference between the % of value added in manufacturing in Benin and % of value added in manufacturing in Nicaragua?
Your answer should be very brief. -5.09. In the year 1977, what is the difference between the % of value added in manufacturing in Benin and % of value added in manufacturing in Syrian Arab Republic?
Your answer should be compact. 1.77. In the year 1977, what is the difference between the % of value added in manufacturing in Cote d'Ivoire and % of value added in manufacturing in Nicaragua?
Your response must be concise. -3.9. In the year 1977, what is the difference between the % of value added in manufacturing in Cote d'Ivoire and % of value added in manufacturing in Syrian Arab Republic?
Ensure brevity in your answer.  2.96. In the year 1977, what is the difference between the % of value added in manufacturing of Nicaragua and % of value added in manufacturing of Syrian Arab Republic?
Give a very brief answer. 6.86. In the year 1978, what is the difference between the % of value added in manufacturing in Benin and % of value added in manufacturing in Cote d'Ivoire?
Offer a very short reply. -3.46. In the year 1978, what is the difference between the % of value added in manufacturing of Benin and % of value added in manufacturing of Nicaragua?
Make the answer very short. -5.09. In the year 1978, what is the difference between the % of value added in manufacturing in Benin and % of value added in manufacturing in Syrian Arab Republic?
Keep it short and to the point. -0.16. In the year 1978, what is the difference between the % of value added in manufacturing of Cote d'Ivoire and % of value added in manufacturing of Nicaragua?
Your answer should be compact. -1.63. In the year 1978, what is the difference between the % of value added in manufacturing of Cote d'Ivoire and % of value added in manufacturing of Syrian Arab Republic?
Make the answer very short. 3.31. In the year 1978, what is the difference between the % of value added in manufacturing of Nicaragua and % of value added in manufacturing of Syrian Arab Republic?
Your answer should be compact. 4.94. In the year 1979, what is the difference between the % of value added in manufacturing of Benin and % of value added in manufacturing of Cote d'Ivoire?
Offer a terse response. -2.98. In the year 1979, what is the difference between the % of value added in manufacturing in Benin and % of value added in manufacturing in Nicaragua?
Your answer should be compact. -5.51. In the year 1979, what is the difference between the % of value added in manufacturing of Benin and % of value added in manufacturing of Syrian Arab Republic?
Your response must be concise. 0.31. In the year 1979, what is the difference between the % of value added in manufacturing of Cote d'Ivoire and % of value added in manufacturing of Nicaragua?
Provide a succinct answer. -2.53. In the year 1979, what is the difference between the % of value added in manufacturing of Cote d'Ivoire and % of value added in manufacturing of Syrian Arab Republic?
Offer a very short reply. 3.29. In the year 1979, what is the difference between the % of value added in manufacturing of Nicaragua and % of value added in manufacturing of Syrian Arab Republic?
Your response must be concise. 5.82. In the year 1980, what is the difference between the % of value added in manufacturing of Benin and % of value added in manufacturing of Cote d'Ivoire?
Provide a short and direct response. -0.59. In the year 1980, what is the difference between the % of value added in manufacturing of Benin and % of value added in manufacturing of Nicaragua?
Make the answer very short. -4.8. In the year 1980, what is the difference between the % of value added in manufacturing of Cote d'Ivoire and % of value added in manufacturing of Nicaragua?
Provide a succinct answer. -4.21. In the year 1981, what is the difference between the % of value added in manufacturing of Benin and % of value added in manufacturing of Cote d'Ivoire?
Your response must be concise. -0.3. In the year 1981, what is the difference between the % of value added in manufacturing of Benin and % of value added in manufacturing of Nicaragua?
Your response must be concise. -4.2. In the year 1981, what is the difference between the % of value added in manufacturing in Benin and % of value added in manufacturing in Syrian Arab Republic?
Offer a very short reply. -20.24. In the year 1981, what is the difference between the % of value added in manufacturing in Cote d'Ivoire and % of value added in manufacturing in Nicaragua?
Offer a terse response. -3.91. In the year 1981, what is the difference between the % of value added in manufacturing of Cote d'Ivoire and % of value added in manufacturing of Syrian Arab Republic?
Your answer should be compact. -19.95. In the year 1981, what is the difference between the % of value added in manufacturing in Nicaragua and % of value added in manufacturing in Syrian Arab Republic?
Ensure brevity in your answer.  -16.04. What is the ratio of the % of value added in manufacturing in Benin in 1974 to that in 1975?
Make the answer very short. 0.93. What is the ratio of the % of value added in manufacturing of Cote d'Ivoire in 1974 to that in 1975?
Give a very brief answer. 0.75. What is the ratio of the % of value added in manufacturing in Nicaragua in 1974 to that in 1975?
Make the answer very short. 1.12. What is the ratio of the % of value added in manufacturing of Syrian Arab Republic in 1974 to that in 1975?
Give a very brief answer. 0.81. What is the ratio of the % of value added in manufacturing in Benin in 1974 to that in 1976?
Provide a short and direct response. 0.78. What is the ratio of the % of value added in manufacturing in Cote d'Ivoire in 1974 to that in 1976?
Offer a very short reply. 0.72. What is the ratio of the % of value added in manufacturing of Nicaragua in 1974 to that in 1976?
Offer a terse response. 1.11. What is the ratio of the % of value added in manufacturing in Syrian Arab Republic in 1974 to that in 1976?
Your response must be concise. 0.67. What is the ratio of the % of value added in manufacturing in Benin in 1974 to that in 1977?
Your response must be concise. 0.71. What is the ratio of the % of value added in manufacturing of Cote d'Ivoire in 1974 to that in 1977?
Your response must be concise. 0.98. What is the ratio of the % of value added in manufacturing of Nicaragua in 1974 to that in 1977?
Offer a very short reply. 1.04. What is the ratio of the % of value added in manufacturing of Syrian Arab Republic in 1974 to that in 1977?
Provide a short and direct response. 0.64. What is the ratio of the % of value added in manufacturing in Benin in 1974 to that in 1978?
Your response must be concise. 0.9. What is the ratio of the % of value added in manufacturing in Cote d'Ivoire in 1974 to that in 1978?
Offer a terse response. 0.79. What is the ratio of the % of value added in manufacturing of Nicaragua in 1974 to that in 1978?
Your response must be concise. 1.15. What is the ratio of the % of value added in manufacturing of Syrian Arab Republic in 1974 to that in 1978?
Provide a succinct answer. 0.46. What is the ratio of the % of value added in manufacturing in Benin in 1974 to that in 1979?
Provide a short and direct response. 0.74. What is the ratio of the % of value added in manufacturing in Cote d'Ivoire in 1974 to that in 1979?
Your answer should be very brief. 0.76. What is the ratio of the % of value added in manufacturing of Nicaragua in 1974 to that in 1979?
Offer a very short reply. 1.01. What is the ratio of the % of value added in manufacturing in Syrian Arab Republic in 1974 to that in 1979?
Provide a succinct answer. 0.43. What is the ratio of the % of value added in manufacturing of Benin in 1974 to that in 1980?
Give a very brief answer. 0.54. What is the ratio of the % of value added in manufacturing in Cote d'Ivoire in 1974 to that in 1980?
Your answer should be very brief. 0.87. What is the ratio of the % of value added in manufacturing of Nicaragua in 1974 to that in 1980?
Offer a very short reply. 0.94. What is the ratio of the % of value added in manufacturing of Benin in 1974 to that in 1981?
Offer a very short reply. 0.47. What is the ratio of the % of value added in manufacturing in Cote d'Ivoire in 1974 to that in 1981?
Your answer should be very brief. 0.79. What is the ratio of the % of value added in manufacturing of Nicaragua in 1974 to that in 1981?
Offer a terse response. 0.91. What is the ratio of the % of value added in manufacturing in Syrian Arab Republic in 1974 to that in 1981?
Your response must be concise. 0.06. What is the ratio of the % of value added in manufacturing in Benin in 1975 to that in 1976?
Provide a short and direct response. 0.84. What is the ratio of the % of value added in manufacturing of Cote d'Ivoire in 1975 to that in 1976?
Offer a terse response. 0.96. What is the ratio of the % of value added in manufacturing of Nicaragua in 1975 to that in 1976?
Ensure brevity in your answer.  0.99. What is the ratio of the % of value added in manufacturing in Syrian Arab Republic in 1975 to that in 1976?
Provide a succinct answer. 0.83. What is the ratio of the % of value added in manufacturing of Benin in 1975 to that in 1977?
Your answer should be compact. 0.77. What is the ratio of the % of value added in manufacturing in Cote d'Ivoire in 1975 to that in 1977?
Make the answer very short. 1.31. What is the ratio of the % of value added in manufacturing of Nicaragua in 1975 to that in 1977?
Give a very brief answer. 0.93. What is the ratio of the % of value added in manufacturing in Syrian Arab Republic in 1975 to that in 1977?
Your answer should be compact. 0.79. What is the ratio of the % of value added in manufacturing of Benin in 1975 to that in 1978?
Keep it short and to the point. 0.97. What is the ratio of the % of value added in manufacturing of Cote d'Ivoire in 1975 to that in 1978?
Offer a very short reply. 1.05. What is the ratio of the % of value added in manufacturing in Nicaragua in 1975 to that in 1978?
Your answer should be compact. 1.02. What is the ratio of the % of value added in manufacturing of Syrian Arab Republic in 1975 to that in 1978?
Give a very brief answer. 0.57. What is the ratio of the % of value added in manufacturing of Benin in 1975 to that in 1979?
Your response must be concise. 0.8. What is the ratio of the % of value added in manufacturing of Cote d'Ivoire in 1975 to that in 1979?
Make the answer very short. 1.02. What is the ratio of the % of value added in manufacturing of Nicaragua in 1975 to that in 1979?
Ensure brevity in your answer.  0.91. What is the ratio of the % of value added in manufacturing in Syrian Arab Republic in 1975 to that in 1979?
Ensure brevity in your answer.  0.53. What is the ratio of the % of value added in manufacturing in Benin in 1975 to that in 1980?
Your answer should be compact. 0.59. What is the ratio of the % of value added in manufacturing in Cote d'Ivoire in 1975 to that in 1980?
Offer a terse response. 1.16. What is the ratio of the % of value added in manufacturing in Nicaragua in 1975 to that in 1980?
Make the answer very short. 0.83. What is the ratio of the % of value added in manufacturing of Benin in 1975 to that in 1981?
Keep it short and to the point. 0.51. What is the ratio of the % of value added in manufacturing of Cote d'Ivoire in 1975 to that in 1981?
Give a very brief answer. 1.06. What is the ratio of the % of value added in manufacturing of Nicaragua in 1975 to that in 1981?
Ensure brevity in your answer.  0.81. What is the ratio of the % of value added in manufacturing of Syrian Arab Republic in 1975 to that in 1981?
Keep it short and to the point. 0.08. What is the ratio of the % of value added in manufacturing of Benin in 1976 to that in 1977?
Provide a short and direct response. 0.92. What is the ratio of the % of value added in manufacturing of Cote d'Ivoire in 1976 to that in 1977?
Keep it short and to the point. 1.36. What is the ratio of the % of value added in manufacturing in Nicaragua in 1976 to that in 1977?
Your answer should be compact. 0.94. What is the ratio of the % of value added in manufacturing in Syrian Arab Republic in 1976 to that in 1977?
Provide a short and direct response. 0.95. What is the ratio of the % of value added in manufacturing of Benin in 1976 to that in 1978?
Your answer should be very brief. 1.15. What is the ratio of the % of value added in manufacturing in Cote d'Ivoire in 1976 to that in 1978?
Ensure brevity in your answer.  1.09. What is the ratio of the % of value added in manufacturing in Nicaragua in 1976 to that in 1978?
Your answer should be compact. 1.04. What is the ratio of the % of value added in manufacturing of Syrian Arab Republic in 1976 to that in 1978?
Provide a succinct answer. 0.68. What is the ratio of the % of value added in manufacturing of Benin in 1976 to that in 1979?
Give a very brief answer. 0.96. What is the ratio of the % of value added in manufacturing of Cote d'Ivoire in 1976 to that in 1979?
Your answer should be compact. 1.06. What is the ratio of the % of value added in manufacturing of Nicaragua in 1976 to that in 1979?
Provide a short and direct response. 0.92. What is the ratio of the % of value added in manufacturing in Syrian Arab Republic in 1976 to that in 1979?
Your answer should be very brief. 0.64. What is the ratio of the % of value added in manufacturing in Benin in 1976 to that in 1980?
Offer a terse response. 0.7. What is the ratio of the % of value added in manufacturing of Cote d'Ivoire in 1976 to that in 1980?
Make the answer very short. 1.2. What is the ratio of the % of value added in manufacturing in Nicaragua in 1976 to that in 1980?
Your answer should be very brief. 0.84. What is the ratio of the % of value added in manufacturing in Benin in 1976 to that in 1981?
Keep it short and to the point. 0.61. What is the ratio of the % of value added in manufacturing in Cote d'Ivoire in 1976 to that in 1981?
Ensure brevity in your answer.  1.1. What is the ratio of the % of value added in manufacturing in Nicaragua in 1976 to that in 1981?
Make the answer very short. 0.82. What is the ratio of the % of value added in manufacturing in Syrian Arab Republic in 1976 to that in 1981?
Your answer should be compact. 0.09. What is the ratio of the % of value added in manufacturing in Benin in 1977 to that in 1978?
Your answer should be very brief. 1.26. What is the ratio of the % of value added in manufacturing of Cote d'Ivoire in 1977 to that in 1978?
Keep it short and to the point. 0.8. What is the ratio of the % of value added in manufacturing of Nicaragua in 1977 to that in 1978?
Offer a very short reply. 1.1. What is the ratio of the % of value added in manufacturing of Syrian Arab Republic in 1977 to that in 1978?
Give a very brief answer. 0.72. What is the ratio of the % of value added in manufacturing of Benin in 1977 to that in 1979?
Provide a succinct answer. 1.05. What is the ratio of the % of value added in manufacturing of Cote d'Ivoire in 1977 to that in 1979?
Your answer should be very brief. 0.78. What is the ratio of the % of value added in manufacturing of Nicaragua in 1977 to that in 1979?
Offer a very short reply. 0.98. What is the ratio of the % of value added in manufacturing of Syrian Arab Republic in 1977 to that in 1979?
Offer a terse response. 0.67. What is the ratio of the % of value added in manufacturing of Benin in 1977 to that in 1980?
Your answer should be compact. 0.77. What is the ratio of the % of value added in manufacturing of Cote d'Ivoire in 1977 to that in 1980?
Give a very brief answer. 0.88. What is the ratio of the % of value added in manufacturing of Nicaragua in 1977 to that in 1980?
Ensure brevity in your answer.  0.9. What is the ratio of the % of value added in manufacturing in Benin in 1977 to that in 1981?
Your answer should be very brief. 0.66. What is the ratio of the % of value added in manufacturing in Cote d'Ivoire in 1977 to that in 1981?
Ensure brevity in your answer.  0.81. What is the ratio of the % of value added in manufacturing of Nicaragua in 1977 to that in 1981?
Keep it short and to the point. 0.88. What is the ratio of the % of value added in manufacturing of Syrian Arab Republic in 1977 to that in 1981?
Give a very brief answer. 0.1. What is the ratio of the % of value added in manufacturing in Benin in 1978 to that in 1979?
Your answer should be very brief. 0.83. What is the ratio of the % of value added in manufacturing in Cote d'Ivoire in 1978 to that in 1979?
Offer a very short reply. 0.97. What is the ratio of the % of value added in manufacturing in Nicaragua in 1978 to that in 1979?
Your answer should be compact. 0.88. What is the ratio of the % of value added in manufacturing in Syrian Arab Republic in 1978 to that in 1979?
Give a very brief answer. 0.94. What is the ratio of the % of value added in manufacturing in Benin in 1978 to that in 1980?
Your answer should be very brief. 0.61. What is the ratio of the % of value added in manufacturing of Cote d'Ivoire in 1978 to that in 1980?
Your response must be concise. 1.1. What is the ratio of the % of value added in manufacturing in Nicaragua in 1978 to that in 1980?
Your answer should be compact. 0.81. What is the ratio of the % of value added in manufacturing of Benin in 1978 to that in 1981?
Offer a terse response. 0.53. What is the ratio of the % of value added in manufacturing in Cote d'Ivoire in 1978 to that in 1981?
Your answer should be compact. 1.01. What is the ratio of the % of value added in manufacturing of Nicaragua in 1978 to that in 1981?
Give a very brief answer. 0.79. What is the ratio of the % of value added in manufacturing in Syrian Arab Republic in 1978 to that in 1981?
Keep it short and to the point. 0.13. What is the ratio of the % of value added in manufacturing in Benin in 1979 to that in 1980?
Provide a succinct answer. 0.73. What is the ratio of the % of value added in manufacturing of Cote d'Ivoire in 1979 to that in 1980?
Your answer should be compact. 1.14. What is the ratio of the % of value added in manufacturing of Nicaragua in 1979 to that in 1980?
Your response must be concise. 0.92. What is the ratio of the % of value added in manufacturing of Benin in 1979 to that in 1981?
Your answer should be compact. 0.63. What is the ratio of the % of value added in manufacturing of Cote d'Ivoire in 1979 to that in 1981?
Your answer should be very brief. 1.04. What is the ratio of the % of value added in manufacturing of Nicaragua in 1979 to that in 1981?
Give a very brief answer. 0.9. What is the ratio of the % of value added in manufacturing of Syrian Arab Republic in 1979 to that in 1981?
Give a very brief answer. 0.14. What is the ratio of the % of value added in manufacturing of Benin in 1980 to that in 1981?
Your response must be concise. 0.87. What is the ratio of the % of value added in manufacturing in Cote d'Ivoire in 1980 to that in 1981?
Your response must be concise. 0.92. What is the ratio of the % of value added in manufacturing in Nicaragua in 1980 to that in 1981?
Provide a short and direct response. 0.97. What is the difference between the highest and the second highest % of value added in manufacturing of Benin?
Ensure brevity in your answer.  0.88. What is the difference between the highest and the second highest % of value added in manufacturing of Cote d'Ivoire?
Your answer should be compact. 0.27. What is the difference between the highest and the second highest % of value added in manufacturing of Nicaragua?
Keep it short and to the point. 0.27. What is the difference between the highest and the second highest % of value added in manufacturing of Syrian Arab Republic?
Your response must be concise. 22.95. What is the difference between the highest and the lowest % of value added in manufacturing in Benin?
Make the answer very short. 3.47. What is the difference between the highest and the lowest % of value added in manufacturing in Cote d'Ivoire?
Your answer should be compact. 2.12. What is the difference between the highest and the lowest % of value added in manufacturing in Nicaragua?
Keep it short and to the point. 2.22. What is the difference between the highest and the lowest % of value added in manufacturing in Syrian Arab Republic?
Give a very brief answer. 26.81. 